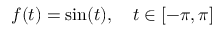Convert formula to latex. <formula><loc_0><loc_0><loc_500><loc_500>f ( t ) = \sin ( t ) , \quad t \in [ - \pi , \pi ]</formula> 